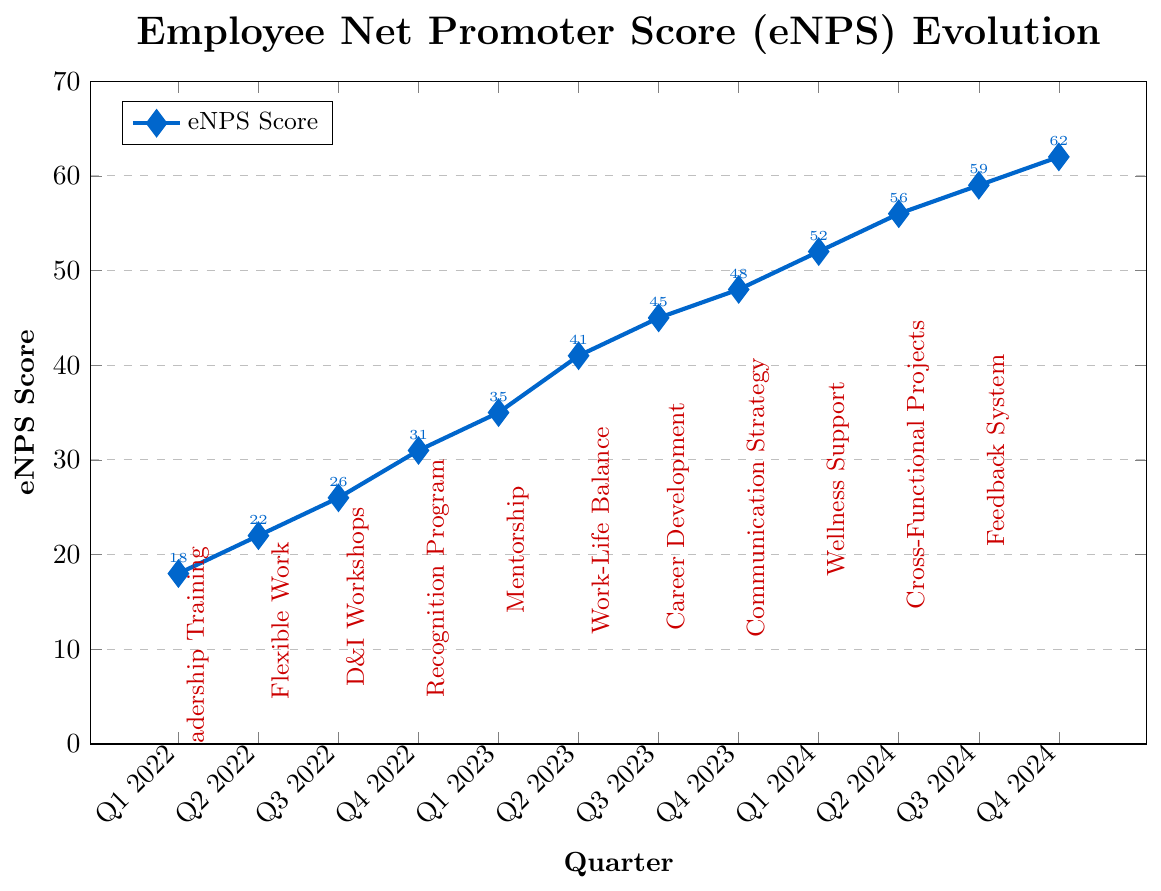What was the eNPS score at Q2 2023? Look at the plot's data point for the quarter labeled Q2 2023, where the eNPS score is shown near the coordinates.
Answer: 41 Which cultural initiative was implemented in Q1 2023, and what was the corresponding eNPS score? Refer to the red annotation near Q1 2023 for the cultural initiative, and the corresponding blue data point for the eNPS score.
Answer: Employee Recognition Program, 35 How did the eNPS score change from Q1 2022 to Q2 2024? Subtract the eNPS value at Q1 2022 from the value at Q2 2024 (56 - 18).
Answer: 38 Which quarter saw the highest increase in eNPS after implementing a cultural initiative? Identify the largest vertical gap between two consecutive blue data points. The largest increase is between Q1 2023 (35) and Q2 2023 (41).
Answer: Q2 2023 What is the average eNPS score across the entire period from Q1 2022 to Q4 2024? Sum all the eNPS scores and divide by the number of quarters: (18 + 22 + 26 + 31 + 35 + 41 + 45 + 48 + 52 + 56 + 59 + 62) / 12.
Answer: 40.5 Is there a quarter where the eNPS score remained unchanged compared to the previous quarter? Examine if any two consecutive data points have the same eNPS value. No such case exists here.
Answer: No Compare the eNPS scores before and after the Mentorship Initiative. Is there a noticeable increase? Mentorship Initiative was implemented in Q2 2023, so compare Q1 2023 (35) and Q2 2023 (41). Calculate the increase (41 - 35).
Answer: Yes, increase by 6 Estimate the trend in the eNPS score from Q3 2023 to Q4 2024. Does it appear linear or nonlinear? Observe the overall slope of the line formed by these data points. The increase appears relatively steady, indicating a linear trend.
Answer: Linear How much did the eNPS score improve after implementing the Continuous Feedback System? Compare the eNPS scores for Q3 2024 (59) and Q4 2024 (62). Calculate the difference (62 - 59).
Answer: 3 